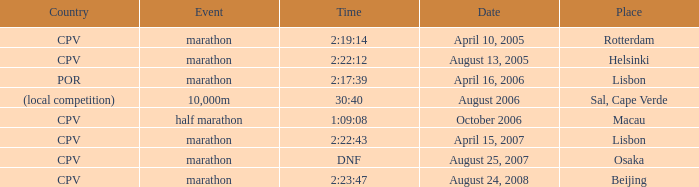What is the occasion named country of (regional contest)? 10,000m. 